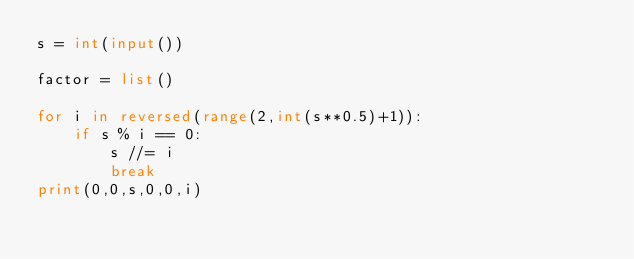Convert code to text. <code><loc_0><loc_0><loc_500><loc_500><_Python_>s = int(input())

factor = list()

for i in reversed(range(2,int(s**0.5)+1)):
    if s % i == 0:
        s //= i
        break
print(0,0,s,0,0,i)</code> 